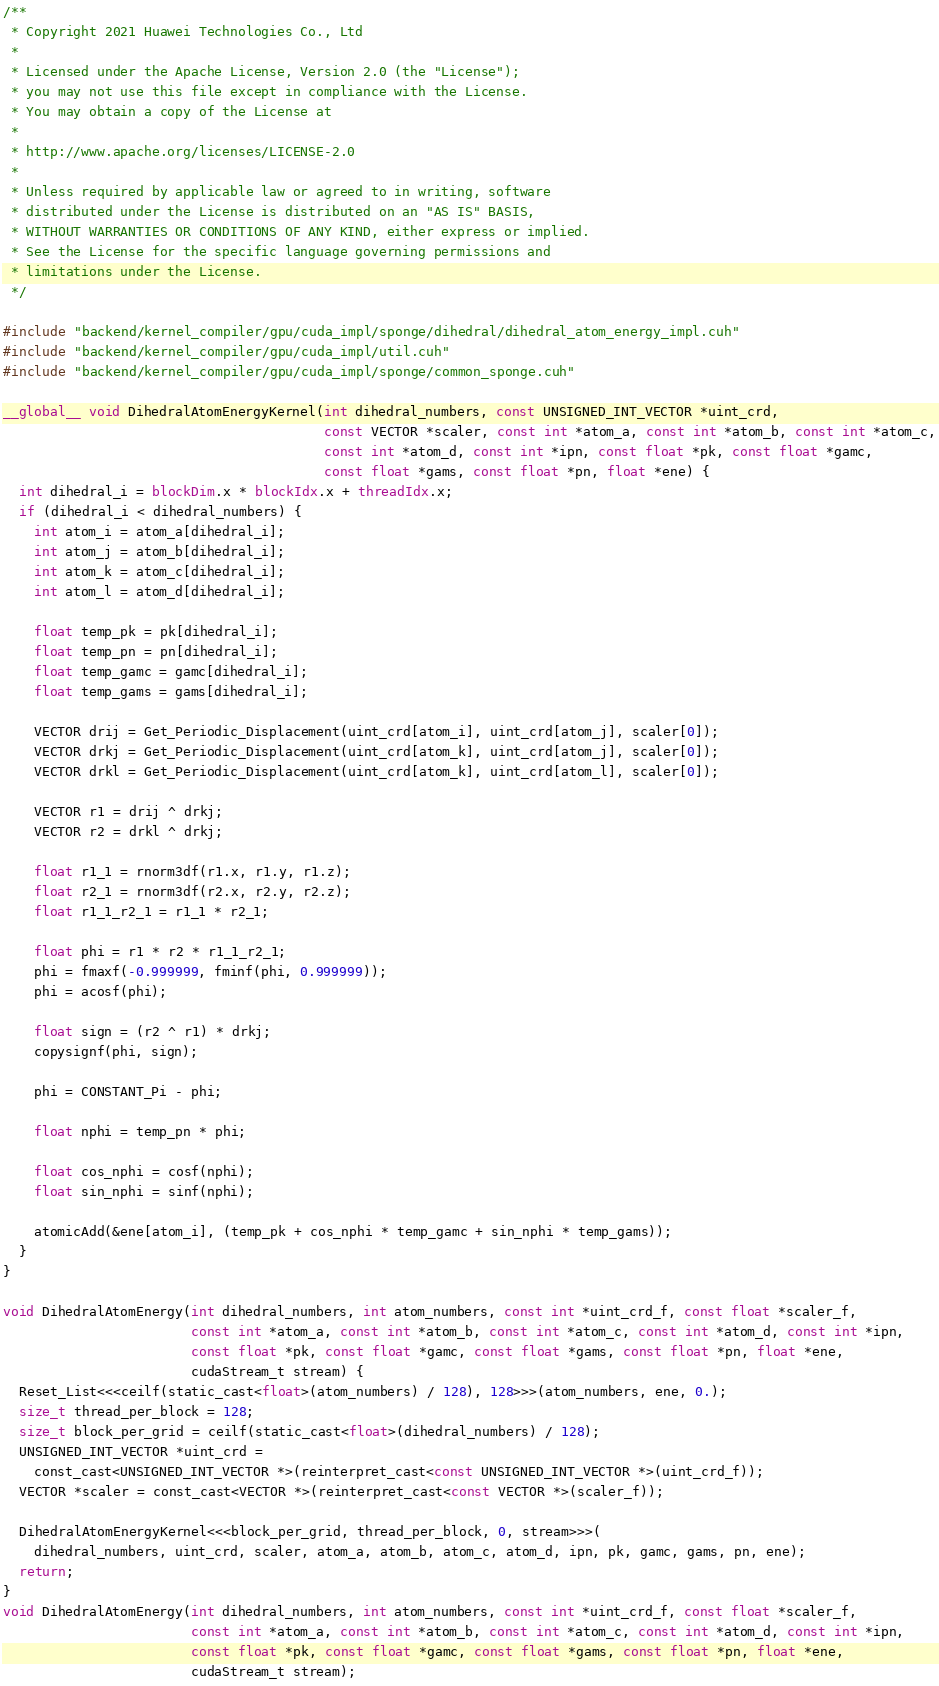Convert code to text. <code><loc_0><loc_0><loc_500><loc_500><_Cuda_>/**
 * Copyright 2021 Huawei Technologies Co., Ltd
 *
 * Licensed under the Apache License, Version 2.0 (the "License");
 * you may not use this file except in compliance with the License.
 * You may obtain a copy of the License at
 *
 * http://www.apache.org/licenses/LICENSE-2.0
 *
 * Unless required by applicable law or agreed to in writing, software
 * distributed under the License is distributed on an "AS IS" BASIS,
 * WITHOUT WARRANTIES OR CONDITIONS OF ANY KIND, either express or implied.
 * See the License for the specific language governing permissions and
 * limitations under the License.
 */

#include "backend/kernel_compiler/gpu/cuda_impl/sponge/dihedral/dihedral_atom_energy_impl.cuh"
#include "backend/kernel_compiler/gpu/cuda_impl/util.cuh"
#include "backend/kernel_compiler/gpu/cuda_impl/sponge/common_sponge.cuh"

__global__ void DihedralAtomEnergyKernel(int dihedral_numbers, const UNSIGNED_INT_VECTOR *uint_crd,
                                         const VECTOR *scaler, const int *atom_a, const int *atom_b, const int *atom_c,
                                         const int *atom_d, const int *ipn, const float *pk, const float *gamc,
                                         const float *gams, const float *pn, float *ene) {
  int dihedral_i = blockDim.x * blockIdx.x + threadIdx.x;
  if (dihedral_i < dihedral_numbers) {
    int atom_i = atom_a[dihedral_i];
    int atom_j = atom_b[dihedral_i];
    int atom_k = atom_c[dihedral_i];
    int atom_l = atom_d[dihedral_i];

    float temp_pk = pk[dihedral_i];
    float temp_pn = pn[dihedral_i];
    float temp_gamc = gamc[dihedral_i];
    float temp_gams = gams[dihedral_i];

    VECTOR drij = Get_Periodic_Displacement(uint_crd[atom_i], uint_crd[atom_j], scaler[0]);
    VECTOR drkj = Get_Periodic_Displacement(uint_crd[atom_k], uint_crd[atom_j], scaler[0]);
    VECTOR drkl = Get_Periodic_Displacement(uint_crd[atom_k], uint_crd[atom_l], scaler[0]);

    VECTOR r1 = drij ^ drkj;
    VECTOR r2 = drkl ^ drkj;

    float r1_1 = rnorm3df(r1.x, r1.y, r1.z);
    float r2_1 = rnorm3df(r2.x, r2.y, r2.z);
    float r1_1_r2_1 = r1_1 * r2_1;

    float phi = r1 * r2 * r1_1_r2_1;
    phi = fmaxf(-0.999999, fminf(phi, 0.999999));
    phi = acosf(phi);

    float sign = (r2 ^ r1) * drkj;
    copysignf(phi, sign);

    phi = CONSTANT_Pi - phi;

    float nphi = temp_pn * phi;

    float cos_nphi = cosf(nphi);
    float sin_nphi = sinf(nphi);

    atomicAdd(&ene[atom_i], (temp_pk + cos_nphi * temp_gamc + sin_nphi * temp_gams));
  }
}

void DihedralAtomEnergy(int dihedral_numbers, int atom_numbers, const int *uint_crd_f, const float *scaler_f,
                        const int *atom_a, const int *atom_b, const int *atom_c, const int *atom_d, const int *ipn,
                        const float *pk, const float *gamc, const float *gams, const float *pn, float *ene,
                        cudaStream_t stream) {
  Reset_List<<<ceilf(static_cast<float>(atom_numbers) / 128), 128>>>(atom_numbers, ene, 0.);
  size_t thread_per_block = 128;
  size_t block_per_grid = ceilf(static_cast<float>(dihedral_numbers) / 128);
  UNSIGNED_INT_VECTOR *uint_crd =
    const_cast<UNSIGNED_INT_VECTOR *>(reinterpret_cast<const UNSIGNED_INT_VECTOR *>(uint_crd_f));
  VECTOR *scaler = const_cast<VECTOR *>(reinterpret_cast<const VECTOR *>(scaler_f));

  DihedralAtomEnergyKernel<<<block_per_grid, thread_per_block, 0, stream>>>(
    dihedral_numbers, uint_crd, scaler, atom_a, atom_b, atom_c, atom_d, ipn, pk, gamc, gams, pn, ene);
  return;
}
void DihedralAtomEnergy(int dihedral_numbers, int atom_numbers, const int *uint_crd_f, const float *scaler_f,
                        const int *atom_a, const int *atom_b, const int *atom_c, const int *atom_d, const int *ipn,
                        const float *pk, const float *gamc, const float *gams, const float *pn, float *ene,
                        cudaStream_t stream);
</code> 